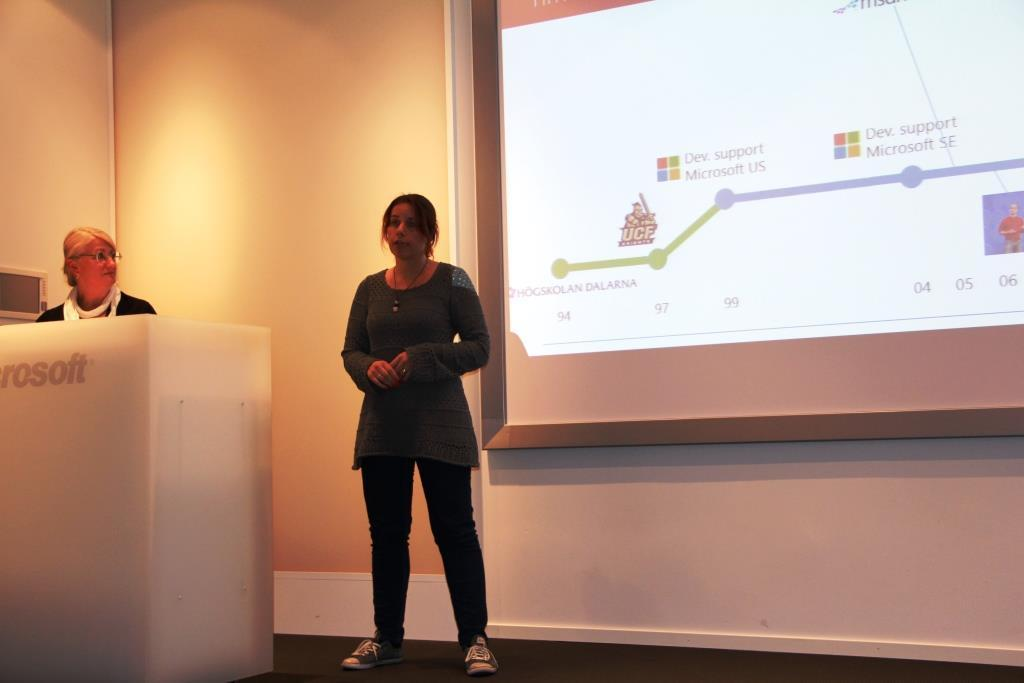Who or what can be seen in the image? There are people in the image. What is the purpose of the screen in the image? The purpose of the screen is not specified, but it is visible in the image. What type of lighting is present in the image? There are lights in the image. Can you describe any other objects in the image? There are some other unspecified objects in the image. Can you tell me how many goldfish are swimming in the image? There are no goldfish present in the image. What type of vein is visible on the person's arm in the image? There is no person's arm visible in the image, and therefore no vein can be observed. 